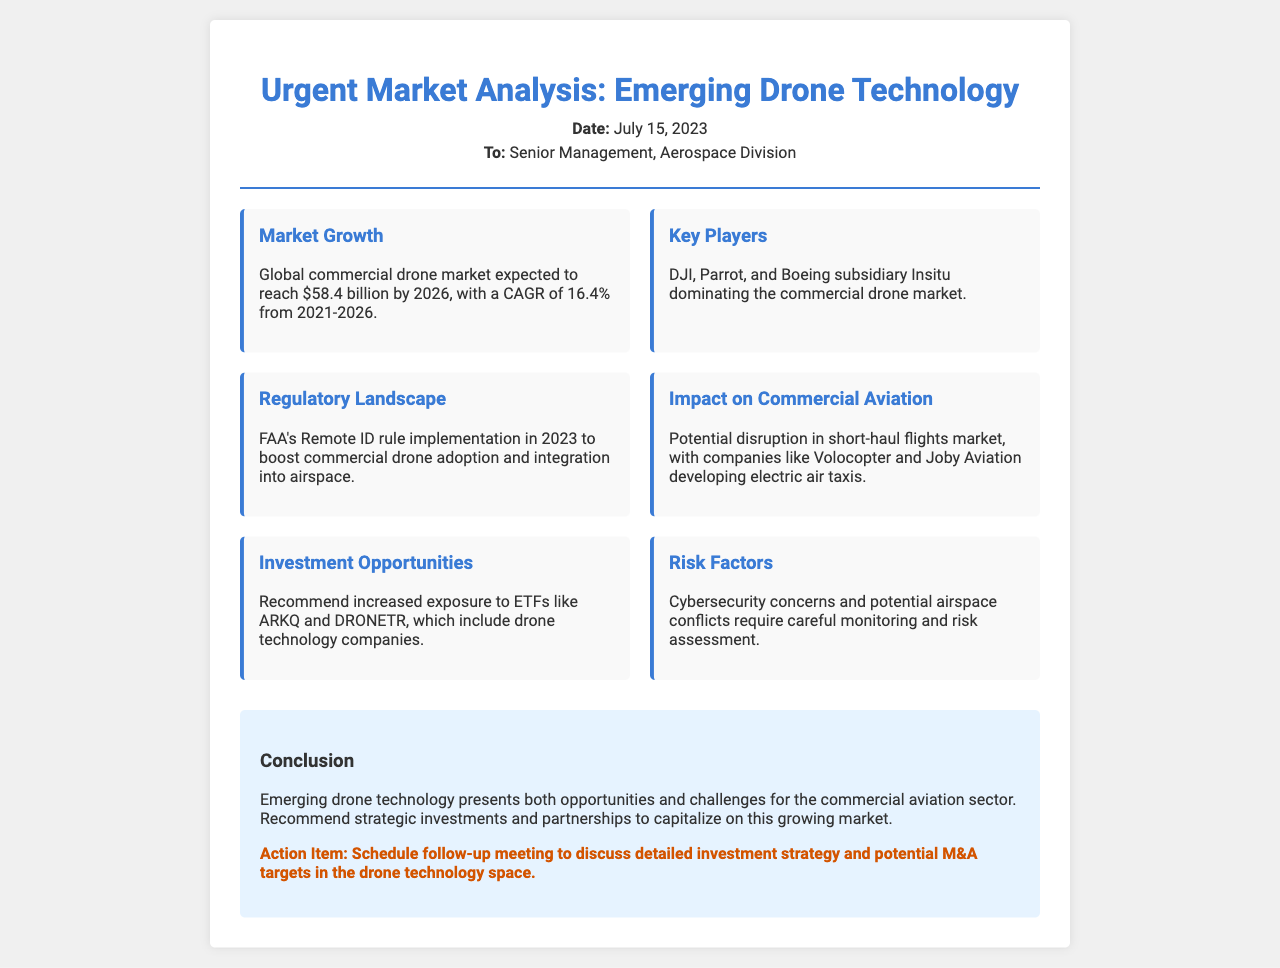What is the expected size of the global commercial drone market by 2026? The document states that the global commercial drone market is expected to reach $58.4 billion by 2026.
Answer: $58.4 billion What is the CAGR for the commercial drone market from 2021 to 2026? The document mentions that the compound annual growth rate (CAGR) from 2021 to 2026 is 16.4%.
Answer: 16.4% Which companies are mentioned as key players in the commercial drone market? The key players listed in the document are DJI, Parrot, and Boeing subsidiary Insitu.
Answer: DJI, Parrot, Insitu What regulatory change is mentioned that will boost drone adoption? The document notes the FAA's Remote ID rule implementation in 2023 as a significant regulatory change.
Answer: FAA's Remote ID rule What companies are identified as developing electric air taxis? The document states that companies like Volocopter and Joby Aviation are developing electric air taxis.
Answer: Volocopter, Joby Aviation What risk factor requires monitoring in the drone market? The document identifies cybersecurity concerns as a significant risk factor that requires careful monitoring.
Answer: Cybersecurity concerns What is the action item recommended at the end of the document? The action item highlighted is to schedule a follow-up meeting to discuss detailed investment strategy and potential M&A targets.
Answer: Schedule follow-up meeting 